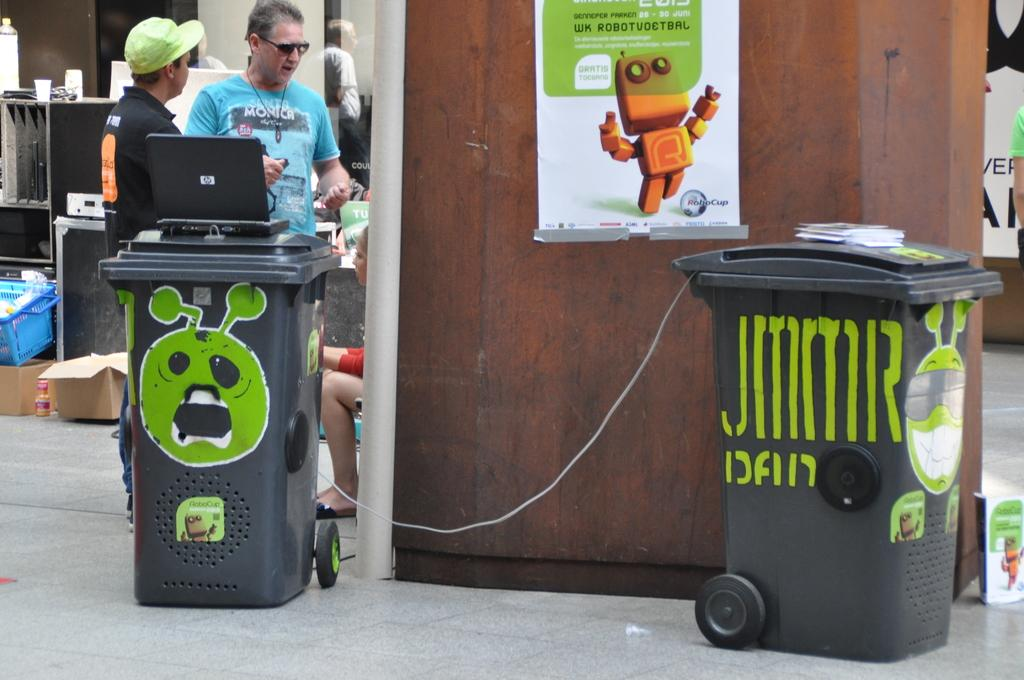How many people are in the image? There is a group of people in the image. Can you describe the woman in the group? A woman is seated among the group. What type of objects are present in the image for waste disposal? Dustbins are present in the image. What electronic device can be seen on one of the dustbins? A laptop is on one of the dustbins. What objects can be seen in the background of the image? There is a basket and a box in the background of the image. Reasoning: Let's think step by step by step in order to produce the conversation. We start by identifying the main subject in the image, which is the group of people. Then, we expand the conversation to include specific details about the woman, the dustbins, the laptop, and the objects in the background. Each question is designed to elicit a specific detail about the image that is known from the provided facts. Absurd Question/Answer: What time does the woman wish to go home in the image? There is no indication of time or the woman's desire to go home in the image. 